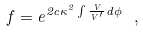Convert formula to latex. <formula><loc_0><loc_0><loc_500><loc_500>f = e ^ { 2 c \kappa ^ { 2 } \int \frac { V } { V ^ { \prime } } d \phi } \ ,</formula> 